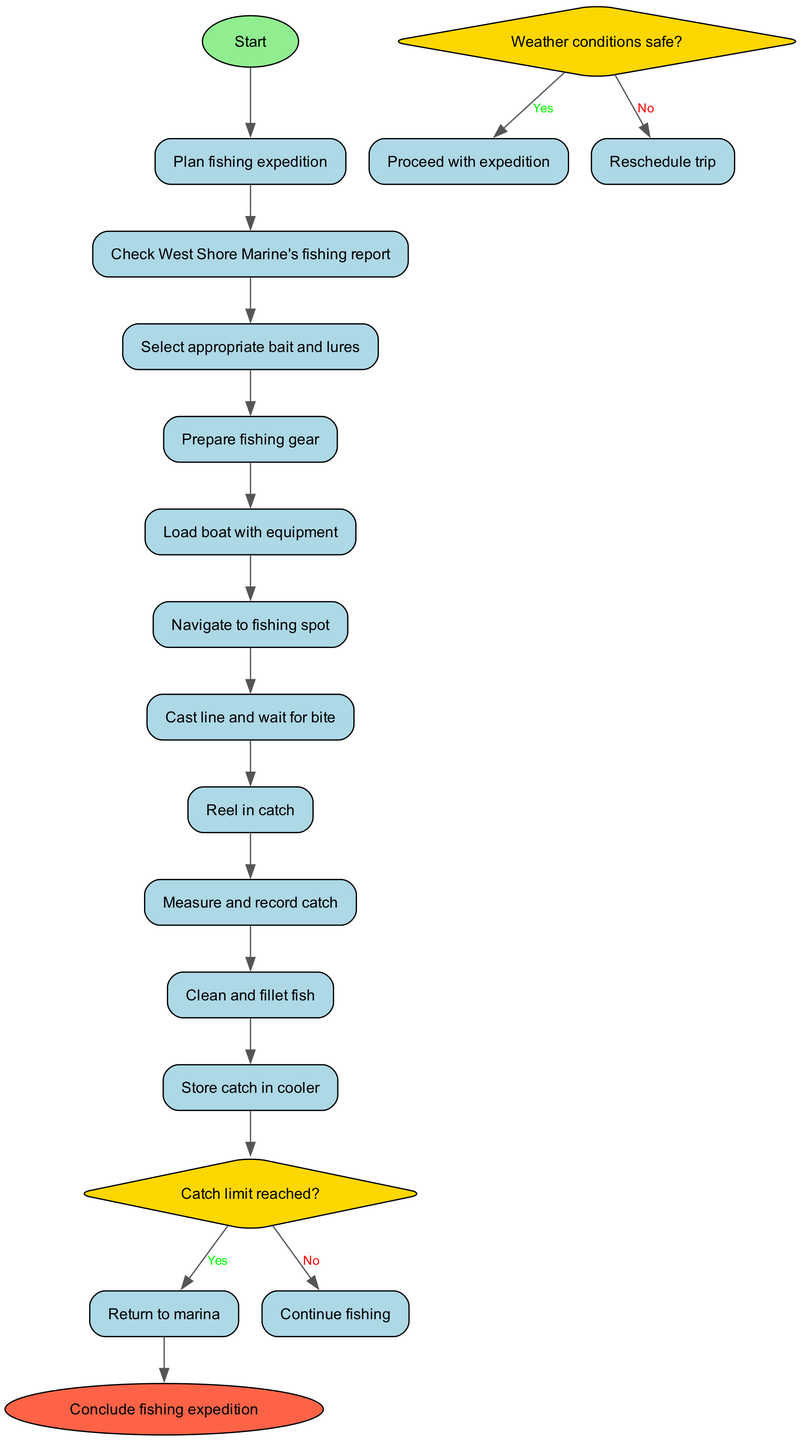What's the first activity in the diagram? The first activity is labeled "Check West Shore Marine's fishing report" and is directly connected to the start node. Therefore, it indicates the initial action to be taken.
Answer: Check West Shore Marine's fishing report How many activities are listed in the diagram? There are a total of 10 activities outlined in the diagram, represented by the sequential nodes between the start and decision nodes.
Answer: 10 What decision follows the activity "Reel in catch"? The decision that follows the activity "Reel in catch" is "Catch limit reached?" which determines the next step based on whether the catch limit is met.
Answer: Catch limit reached? If the answer to "Weather conditions safe?" is no, what is the next step? If the answer to "Weather conditions safe?" is no, the flow directs to "Reschedule trip", indicating that the expedition is postponed due to unsafe weather.
Answer: Reschedule trip What color is the end node in the diagram? The end node is colored in "Tomato", indicating the conclusion of the fishing expedition, visually distinguishing it from other nodes.
Answer: Tomato After measuring and recording the catch, what is the next activity? The next activity after measuring and recording the catch is "Clean and fillet fish", signifying the preparation of the catch for storage or cooking.
Answer: Clean and fillet fish What happens if the catch limit is reached? If the catch limit is reached, the flow directs to "Return to marina", indicating the end of active fishing and the return to the starting point.
Answer: Return to marina What shape is used to represent decisions in the diagram? Decisions are represented by diamonds in the diagram, which is a standard shape used to indicate branching paths based on the outcome of a question.
Answer: Diamond What is the last activity before concluding the fishing expedition? The last activity before concluding the fishing expedition is "Store catch in cooler", indicating the final step in the activity chain before wrapping up.
Answer: Store catch in cooler 